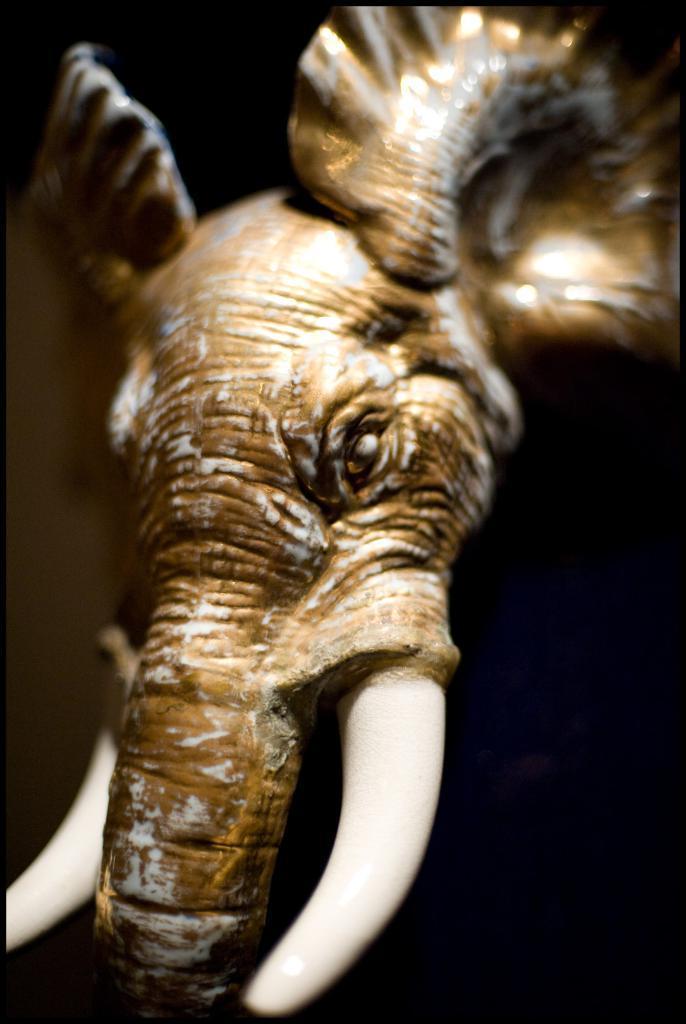Could you give a brief overview of what you see in this image? Here we can see a sculpture and there is a dark background. 